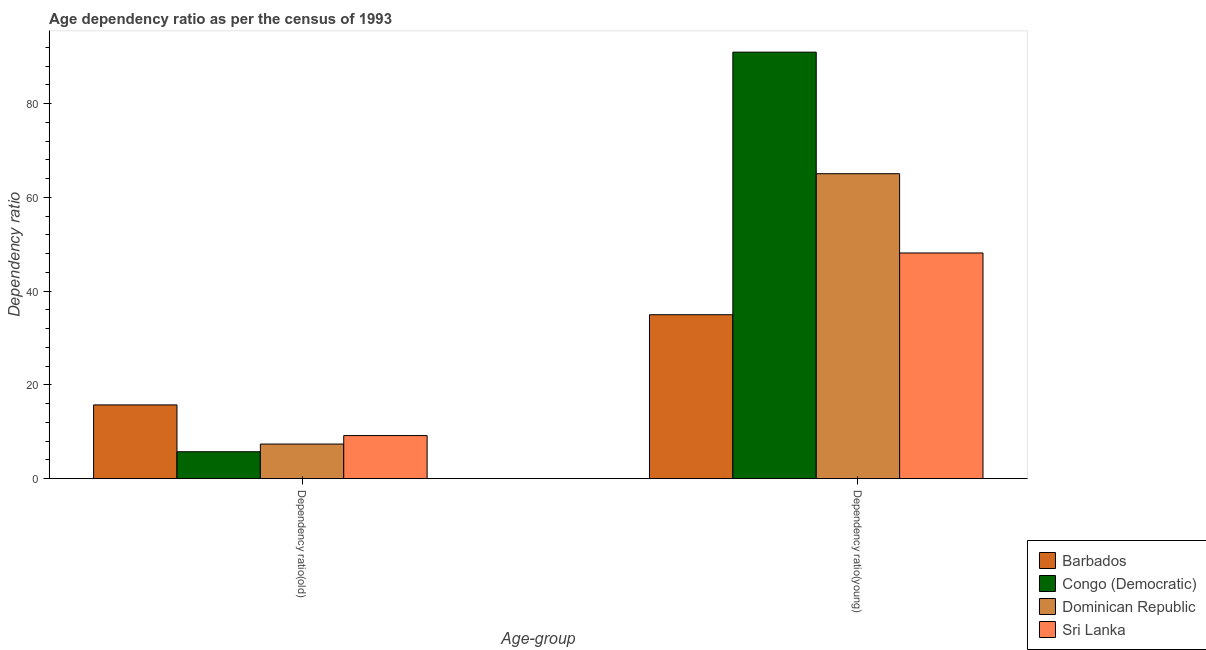How many groups of bars are there?
Provide a short and direct response. 2. Are the number of bars per tick equal to the number of legend labels?
Provide a short and direct response. Yes. What is the label of the 1st group of bars from the left?
Keep it short and to the point. Dependency ratio(old). What is the age dependency ratio(old) in Congo (Democratic)?
Your answer should be very brief. 5.73. Across all countries, what is the maximum age dependency ratio(old)?
Keep it short and to the point. 15.72. Across all countries, what is the minimum age dependency ratio(old)?
Offer a terse response. 5.73. In which country was the age dependency ratio(young) maximum?
Your answer should be very brief. Congo (Democratic). In which country was the age dependency ratio(young) minimum?
Provide a short and direct response. Barbados. What is the total age dependency ratio(young) in the graph?
Keep it short and to the point. 239.11. What is the difference between the age dependency ratio(old) in Sri Lanka and that in Congo (Democratic)?
Offer a very short reply. 3.45. What is the difference between the age dependency ratio(young) in Dominican Republic and the age dependency ratio(old) in Sri Lanka?
Provide a succinct answer. 55.86. What is the average age dependency ratio(old) per country?
Your answer should be very brief. 9.5. What is the difference between the age dependency ratio(young) and age dependency ratio(old) in Congo (Democratic)?
Keep it short and to the point. 85.24. What is the ratio of the age dependency ratio(young) in Congo (Democratic) to that in Dominican Republic?
Your answer should be very brief. 1.4. In how many countries, is the age dependency ratio(young) greater than the average age dependency ratio(young) taken over all countries?
Your answer should be compact. 2. What does the 2nd bar from the left in Dependency ratio(young) represents?
Your answer should be compact. Congo (Democratic). What does the 2nd bar from the right in Dependency ratio(old) represents?
Make the answer very short. Dominican Republic. How many bars are there?
Provide a short and direct response. 8. How many countries are there in the graph?
Provide a short and direct response. 4. What is the difference between two consecutive major ticks on the Y-axis?
Offer a terse response. 20. Are the values on the major ticks of Y-axis written in scientific E-notation?
Your response must be concise. No. Does the graph contain any zero values?
Give a very brief answer. No. Where does the legend appear in the graph?
Ensure brevity in your answer.  Bottom right. How many legend labels are there?
Your answer should be very brief. 4. What is the title of the graph?
Give a very brief answer. Age dependency ratio as per the census of 1993. What is the label or title of the X-axis?
Make the answer very short. Age-group. What is the label or title of the Y-axis?
Offer a terse response. Dependency ratio. What is the Dependency ratio of Barbados in Dependency ratio(old)?
Your response must be concise. 15.72. What is the Dependency ratio of Congo (Democratic) in Dependency ratio(old)?
Provide a short and direct response. 5.73. What is the Dependency ratio in Dominican Republic in Dependency ratio(old)?
Ensure brevity in your answer.  7.37. What is the Dependency ratio in Sri Lanka in Dependency ratio(old)?
Your response must be concise. 9.18. What is the Dependency ratio in Barbados in Dependency ratio(young)?
Offer a terse response. 34.96. What is the Dependency ratio in Congo (Democratic) in Dependency ratio(young)?
Your response must be concise. 90.98. What is the Dependency ratio of Dominican Republic in Dependency ratio(young)?
Your answer should be compact. 65.04. What is the Dependency ratio in Sri Lanka in Dependency ratio(young)?
Make the answer very short. 48.13. Across all Age-group, what is the maximum Dependency ratio in Barbados?
Your answer should be compact. 34.96. Across all Age-group, what is the maximum Dependency ratio in Congo (Democratic)?
Provide a short and direct response. 90.98. Across all Age-group, what is the maximum Dependency ratio of Dominican Republic?
Your answer should be compact. 65.04. Across all Age-group, what is the maximum Dependency ratio of Sri Lanka?
Your answer should be very brief. 48.13. Across all Age-group, what is the minimum Dependency ratio in Barbados?
Offer a terse response. 15.72. Across all Age-group, what is the minimum Dependency ratio of Congo (Democratic)?
Make the answer very short. 5.73. Across all Age-group, what is the minimum Dependency ratio of Dominican Republic?
Keep it short and to the point. 7.37. Across all Age-group, what is the minimum Dependency ratio in Sri Lanka?
Offer a terse response. 9.18. What is the total Dependency ratio in Barbados in the graph?
Make the answer very short. 50.68. What is the total Dependency ratio in Congo (Democratic) in the graph?
Offer a very short reply. 96.71. What is the total Dependency ratio in Dominican Republic in the graph?
Provide a succinct answer. 72.41. What is the total Dependency ratio of Sri Lanka in the graph?
Your answer should be compact. 57.31. What is the difference between the Dependency ratio of Barbados in Dependency ratio(old) and that in Dependency ratio(young)?
Your answer should be compact. -19.24. What is the difference between the Dependency ratio of Congo (Democratic) in Dependency ratio(old) and that in Dependency ratio(young)?
Your response must be concise. -85.24. What is the difference between the Dependency ratio of Dominican Republic in Dependency ratio(old) and that in Dependency ratio(young)?
Give a very brief answer. -57.67. What is the difference between the Dependency ratio of Sri Lanka in Dependency ratio(old) and that in Dependency ratio(young)?
Provide a succinct answer. -38.95. What is the difference between the Dependency ratio in Barbados in Dependency ratio(old) and the Dependency ratio in Congo (Democratic) in Dependency ratio(young)?
Offer a terse response. -75.25. What is the difference between the Dependency ratio of Barbados in Dependency ratio(old) and the Dependency ratio of Dominican Republic in Dependency ratio(young)?
Your answer should be very brief. -49.32. What is the difference between the Dependency ratio of Barbados in Dependency ratio(old) and the Dependency ratio of Sri Lanka in Dependency ratio(young)?
Provide a short and direct response. -32.41. What is the difference between the Dependency ratio in Congo (Democratic) in Dependency ratio(old) and the Dependency ratio in Dominican Republic in Dependency ratio(young)?
Provide a succinct answer. -59.31. What is the difference between the Dependency ratio of Congo (Democratic) in Dependency ratio(old) and the Dependency ratio of Sri Lanka in Dependency ratio(young)?
Keep it short and to the point. -42.4. What is the difference between the Dependency ratio of Dominican Republic in Dependency ratio(old) and the Dependency ratio of Sri Lanka in Dependency ratio(young)?
Keep it short and to the point. -40.76. What is the average Dependency ratio of Barbados per Age-group?
Your answer should be compact. 25.34. What is the average Dependency ratio in Congo (Democratic) per Age-group?
Your answer should be compact. 48.35. What is the average Dependency ratio in Dominican Republic per Age-group?
Your answer should be very brief. 36.21. What is the average Dependency ratio of Sri Lanka per Age-group?
Ensure brevity in your answer.  28.66. What is the difference between the Dependency ratio in Barbados and Dependency ratio in Congo (Democratic) in Dependency ratio(old)?
Provide a succinct answer. 9.99. What is the difference between the Dependency ratio of Barbados and Dependency ratio of Dominican Republic in Dependency ratio(old)?
Keep it short and to the point. 8.35. What is the difference between the Dependency ratio of Barbados and Dependency ratio of Sri Lanka in Dependency ratio(old)?
Provide a succinct answer. 6.54. What is the difference between the Dependency ratio in Congo (Democratic) and Dependency ratio in Dominican Republic in Dependency ratio(old)?
Provide a succinct answer. -1.64. What is the difference between the Dependency ratio of Congo (Democratic) and Dependency ratio of Sri Lanka in Dependency ratio(old)?
Your answer should be very brief. -3.45. What is the difference between the Dependency ratio in Dominican Republic and Dependency ratio in Sri Lanka in Dependency ratio(old)?
Ensure brevity in your answer.  -1.81. What is the difference between the Dependency ratio of Barbados and Dependency ratio of Congo (Democratic) in Dependency ratio(young)?
Offer a terse response. -56.02. What is the difference between the Dependency ratio in Barbados and Dependency ratio in Dominican Republic in Dependency ratio(young)?
Your answer should be compact. -30.08. What is the difference between the Dependency ratio of Barbados and Dependency ratio of Sri Lanka in Dependency ratio(young)?
Keep it short and to the point. -13.17. What is the difference between the Dependency ratio of Congo (Democratic) and Dependency ratio of Dominican Republic in Dependency ratio(young)?
Give a very brief answer. 25.93. What is the difference between the Dependency ratio in Congo (Democratic) and Dependency ratio in Sri Lanka in Dependency ratio(young)?
Make the answer very short. 42.84. What is the difference between the Dependency ratio of Dominican Republic and Dependency ratio of Sri Lanka in Dependency ratio(young)?
Provide a succinct answer. 16.91. What is the ratio of the Dependency ratio in Barbados in Dependency ratio(old) to that in Dependency ratio(young)?
Provide a short and direct response. 0.45. What is the ratio of the Dependency ratio in Congo (Democratic) in Dependency ratio(old) to that in Dependency ratio(young)?
Make the answer very short. 0.06. What is the ratio of the Dependency ratio in Dominican Republic in Dependency ratio(old) to that in Dependency ratio(young)?
Your answer should be compact. 0.11. What is the ratio of the Dependency ratio in Sri Lanka in Dependency ratio(old) to that in Dependency ratio(young)?
Offer a terse response. 0.19. What is the difference between the highest and the second highest Dependency ratio in Barbados?
Offer a very short reply. 19.24. What is the difference between the highest and the second highest Dependency ratio of Congo (Democratic)?
Provide a succinct answer. 85.24. What is the difference between the highest and the second highest Dependency ratio in Dominican Republic?
Keep it short and to the point. 57.67. What is the difference between the highest and the second highest Dependency ratio of Sri Lanka?
Make the answer very short. 38.95. What is the difference between the highest and the lowest Dependency ratio of Barbados?
Your answer should be compact. 19.24. What is the difference between the highest and the lowest Dependency ratio in Congo (Democratic)?
Your answer should be compact. 85.24. What is the difference between the highest and the lowest Dependency ratio of Dominican Republic?
Ensure brevity in your answer.  57.67. What is the difference between the highest and the lowest Dependency ratio in Sri Lanka?
Your response must be concise. 38.95. 